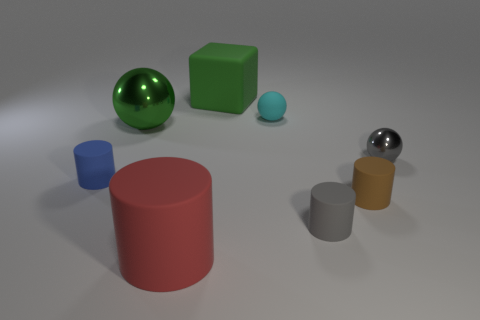Subtract all large cylinders. How many cylinders are left? 3 Add 1 rubber cubes. How many objects exist? 9 Subtract all blue cylinders. How many cylinders are left? 3 Subtract all balls. How many objects are left? 5 Subtract 2 cylinders. How many cylinders are left? 2 Subtract all brown cylinders. Subtract all blue spheres. How many cylinders are left? 3 Subtract all large matte cylinders. Subtract all big green shiny things. How many objects are left? 6 Add 8 gray metallic objects. How many gray metallic objects are left? 9 Add 1 small cyan matte balls. How many small cyan matte balls exist? 2 Subtract 0 red spheres. How many objects are left? 8 